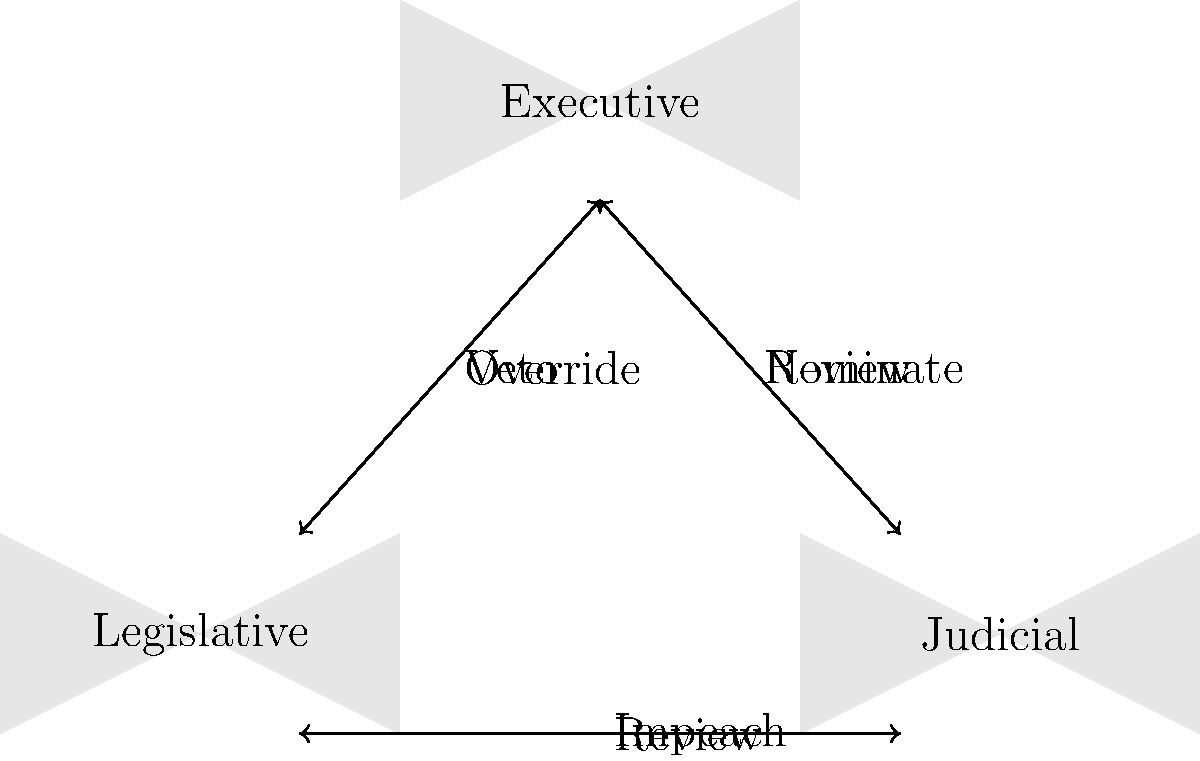Based on the organizational chart of the U.S. government branches, which branch has the power to both nominate Supreme Court justices and veto legislation passed by Congress? To answer this question, let's analyze the organizational chart step-by-step:

1. The chart shows three main boxes representing the three branches of the U.S. government: Executive, Legislative, and Judicial.

2. We need to identify which branch has both the power to nominate Supreme Court justices and veto legislation.

3. Looking at the arrows and their labels:
   a. The arrow labeled "Veto" originates from the Executive branch and points towards the Legislative branch.
   b. The arrow labeled "Nominate" also originates from the Executive branch and points towards the Judicial branch.

4. This indicates that the Executive branch has both the power to veto legislation (interacting with the Legislative branch) and nominate Supreme Court justices (interacting with the Judicial branch).

5. The Executive branch, headed by the President of the United States, is known to have these powers:
   a. The President can veto bills passed by Congress (Legislative branch).
   b. The President nominates Supreme Court justices, who are then confirmed by the Senate (part of the Legislative branch).

6. No other branch in the diagram shows both of these powers simultaneously.

Therefore, based on the organizational chart and the powers indicated by the arrows, the Executive branch is the one that has both the power to nominate Supreme Court justices and veto legislation passed by Congress.
Answer: Executive branch 